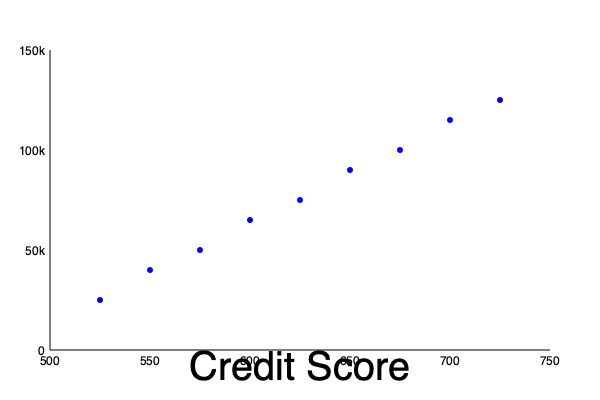Based on the scatter plot showing the relationship between loan amounts and borrower credit scores in predatory lending cases, what can be inferred about the lending practices, and how might this information be used in a consumer rights case? To analyze this scatter plot and its implications for a consumer rights case, let's follow these steps:

1. Observe the general trend:
   The scatter plot shows a positive correlation between credit scores and loan amounts. As credit scores increase, loan amounts tend to increase as well.

2. Assess the strength of the correlation:
   The relationship appears to be moderately strong, as there is a clear upward trend with some variation.

3. Consider the implications:
   a) Higher credit scores generally lead to larger loan amounts, which is expected in legitimate lending practices.
   b) However, in predatory lending cases, this relationship might be exploited.

4. Analyze potential predatory practices:
   a) Loans to low credit score borrowers:
      - These borrowers receive smaller loan amounts, potentially with higher interest rates or unfavorable terms.
      - This could indicate targeting vulnerable borrowers with limited options.

   b) Loans to high credit score borrowers:
      - These borrowers receive larger loan amounts, which could lead to over-lending.
      - Predatory lenders might push unnecessary large loans on creditworthy borrowers.

5. Statistical analysis:
   Calculate the correlation coefficient ($r$) to quantify the relationship. A strong positive correlation could suggest systematic lending practices.

6. Identify outliers:
   Look for data points that deviate significantly from the trend, as these might represent individual cases of predatory lending.

7. Legal implications:
   a) Pattern evidence: The trend could be used to demonstrate systematic predatory practices across a range of credit scores.
   b) Individual cases: Outliers or specific data points could support claims of unfair treatment for particular borrowers.
   c) Comparative analysis: The data could be compared to industry standards to highlight potentially unfair practices.

8. Consumer rights argument:
   This data could be used to argue that the lender is engaging in unfair lending practices across the credit score spectrum, potentially violating consumer protection laws or regulations like the Truth in Lending Act or state predatory lending laws.
Answer: The scatter plot suggests a positive correlation between credit scores and loan amounts, which could indicate systematic lending practices. In a consumer rights case, this data could be used to demonstrate potential predatory lending across various credit scores, supporting arguments of unfair practices and violations of consumer protection laws. 